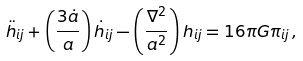<formula> <loc_0><loc_0><loc_500><loc_500>\ddot { h } _ { i j } + \left ( \frac { 3 \dot { a } } { a } \right ) \dot { h } _ { i j } - \left ( \frac { \nabla ^ { 2 } } { a ^ { 2 } } \right ) h _ { i j } = 1 6 \pi G \pi _ { i j } \, ,</formula> 